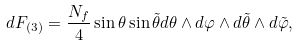<formula> <loc_0><loc_0><loc_500><loc_500>d F _ { ( 3 ) } = \frac { N _ { f } } { 4 } \sin \theta \sin \tilde { \theta } d \theta \wedge d \varphi \wedge d \tilde { \theta } \wedge d \tilde { \varphi } ,</formula> 